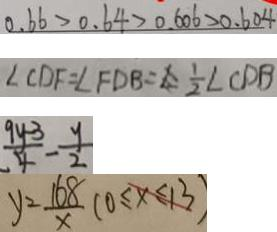Convert formula to latex. <formula><loc_0><loc_0><loc_500><loc_500>0 . 6 6 > 0 . 6 4 > 0 . 6 0 6 > 0 . 6 0 4 
 \angle C D F = \angle F D B = \frac { 1 } { 2 } \angle C D B 
 \frac { 9 y - 3 } { 4 } - \frac { y } { 2 } 
 y = \frac { 1 6 8 } { x } ( 0 \leq x \leq 1 3 )</formula> 